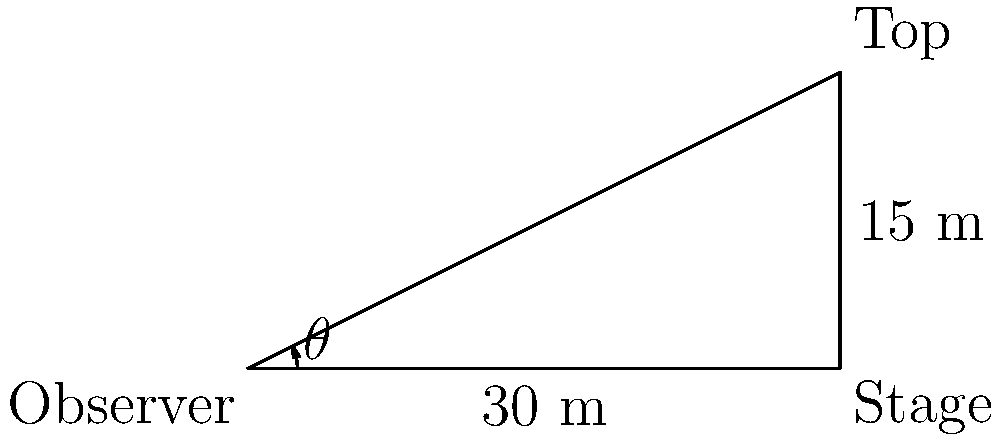At a classic rock concert, you're standing 30 meters away from the stage. The stage is 15 meters tall. What is the angle of elevation, $\theta$, from your position to the top of the stage? Round your answer to the nearest degree. Let's approach this step-by-step using trigonometry:

1) We have a right triangle where:
   - The adjacent side (distance to the stage) is 30 meters
   - The opposite side (height of the stage) is 15 meters
   - We need to find the angle $\theta$

2) In this scenario, we can use the tangent function. Recall that:

   $\tan(\theta) = \frac{\text{opposite}}{\text{adjacent}}$

3) Plugging in our values:

   $\tan(\theta) = \frac{15}{30} = \frac{1}{2} = 0.5$

4) To find $\theta$, we need to use the inverse tangent (arctangent) function:

   $\theta = \tan^{-1}(0.5)$

5) Using a calculator or trigonometric tables:

   $\theta \approx 26.57°$

6) Rounding to the nearest degree:

   $\theta \approx 27°$

Thus, the angle of elevation from your position to the top of the stage is approximately 27 degrees.
Answer: $27°$ 